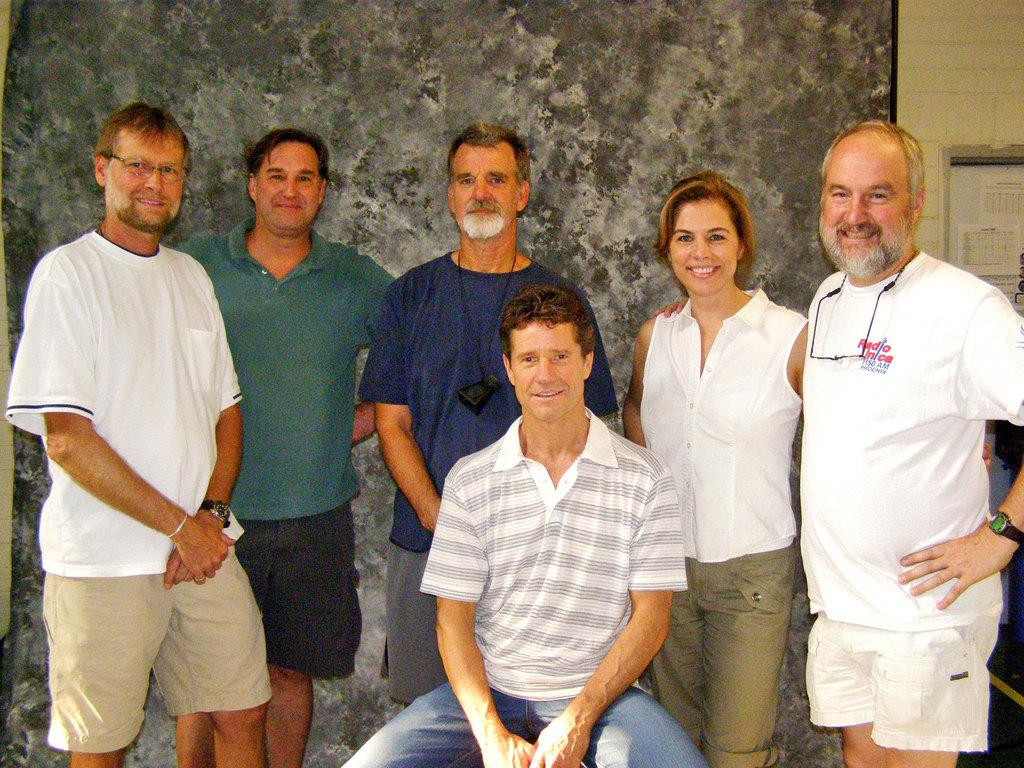How many people are in the image? There is a group of people in the image. What is one person doing in the image? One person is sitting on an object. What can be seen in the background of the image? There is a wall in the background of the image. How many eyes can be seen on the person sitting on the object in the image? There is no information about the number of eyes visible on the person sitting on the object in the image. 